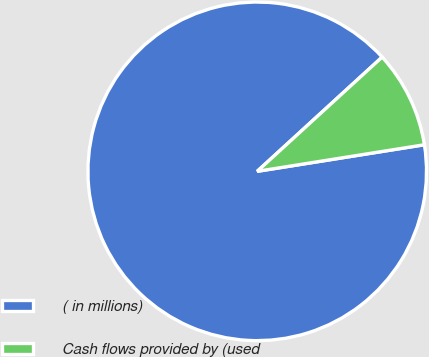Convert chart to OTSL. <chart><loc_0><loc_0><loc_500><loc_500><pie_chart><fcel>( in millions)<fcel>Cash flows provided by (used<nl><fcel>90.72%<fcel>9.28%<nl></chart> 